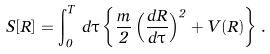<formula> <loc_0><loc_0><loc_500><loc_500>S [ { R } ] = \int _ { 0 } ^ { T } \, d \tau \left \{ \frac { m } { 2 } \left ( \frac { d { R } } { d \tau } \right ) ^ { 2 } + V ( { R } ) \right \} .</formula> 